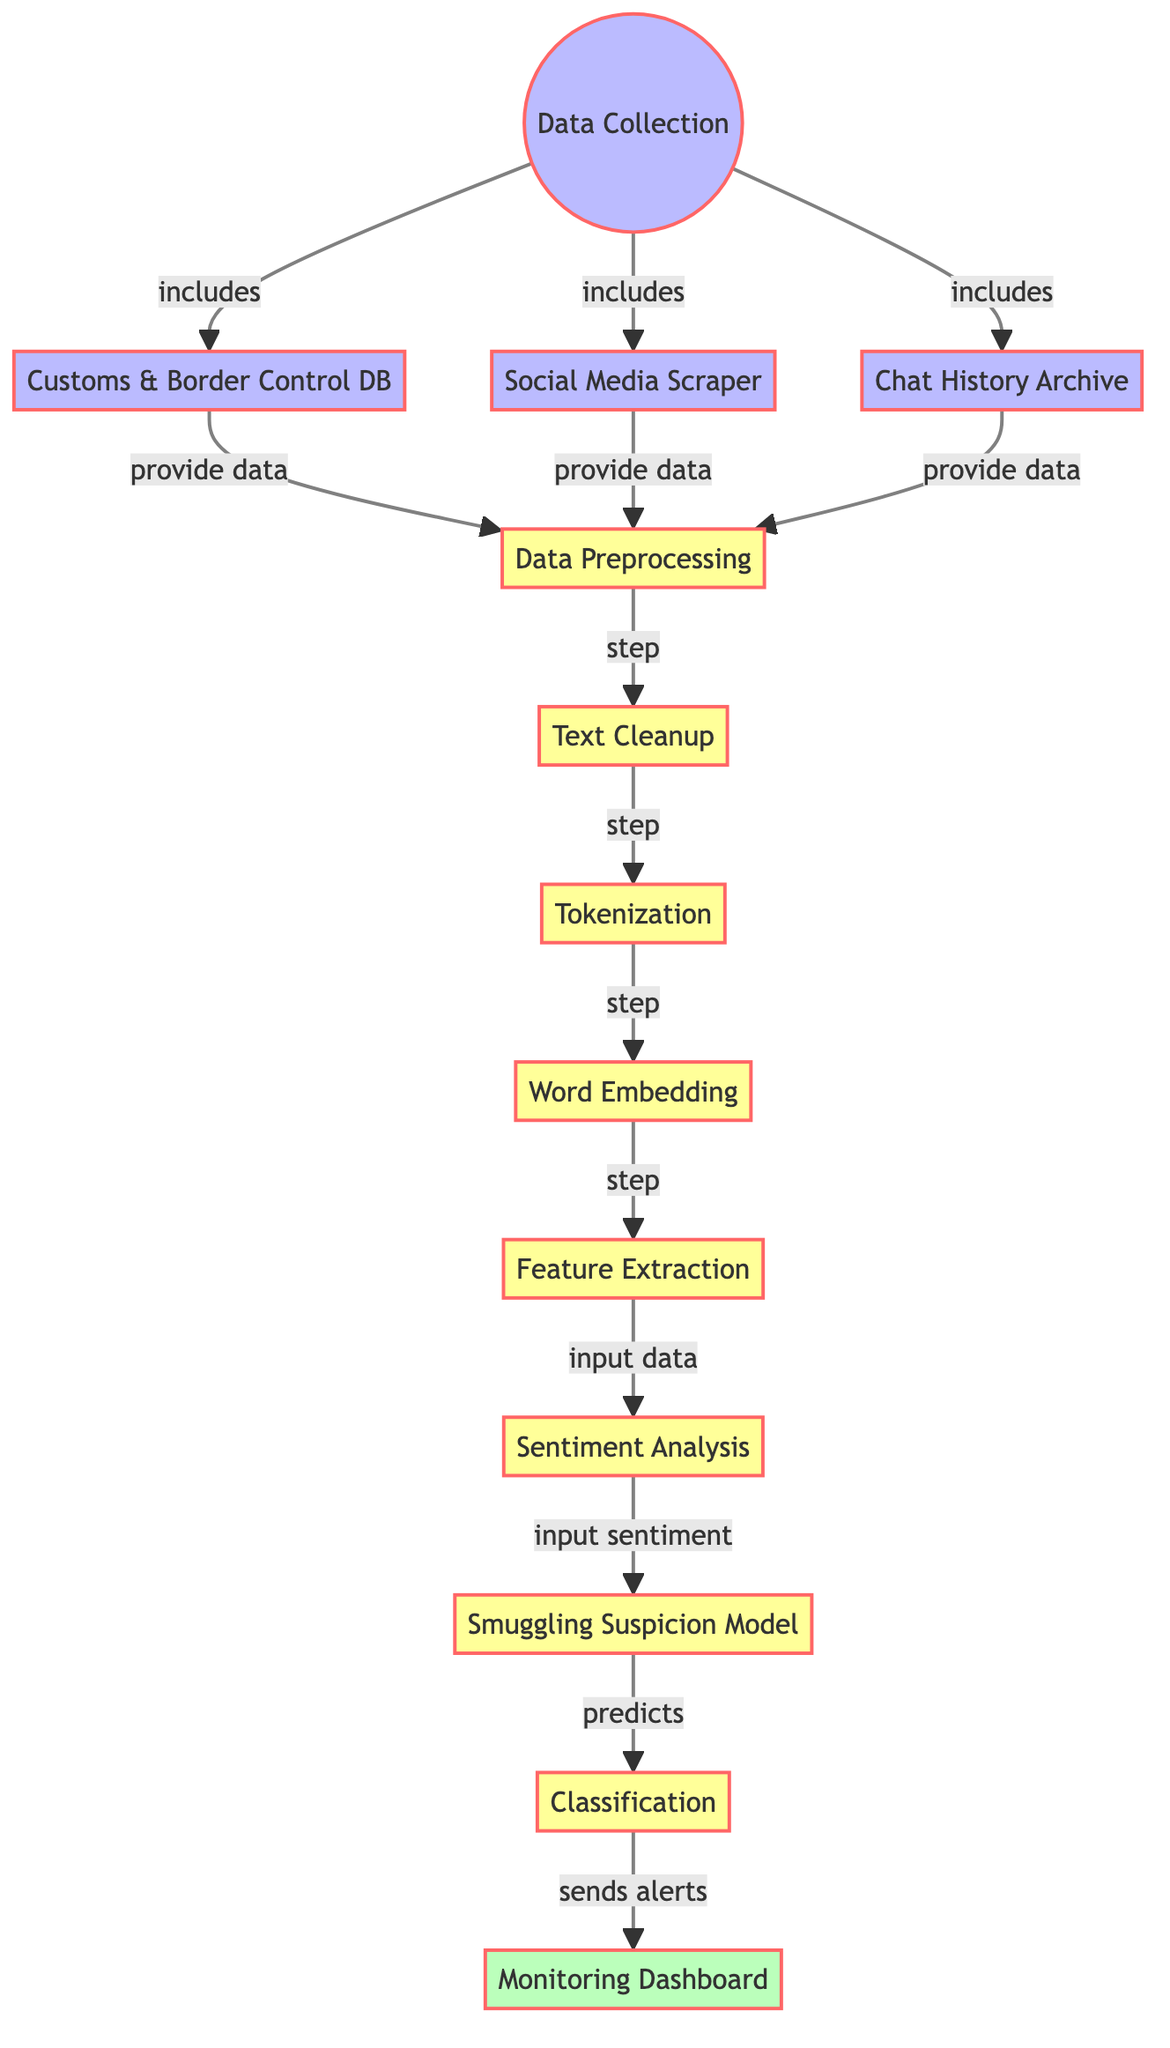What is the first step in the diagram? The diagram starts with "Data Collection", indicating that it's the first step in the process.
Answer: Data Collection How many data sources are there in the data collection step? There are three data sources shown: Customs & Border Control DB, Social Media Scraper, and Chat History Archive, which are all included in data collection.
Answer: Three What process follows text cleanup? According to the diagram, "Tokenization" is the next step that follows text cleanup.
Answer: Tokenization What is the final output of the process? The last node in the flowchart is "Monitoring Dashboard", which represents the final output of the process.
Answer: Monitoring Dashboard What type of model is used after sentiment analysis? The model described following sentiment analysis is labeled as "Smuggling Suspicion Model".
Answer: Smuggling Suspicion Model What does the classification step do? The classification step sends alerts to the monitoring dashboard, indicating its function within the diagram.
Answer: Sends alerts How many total processes are depicted in the diagram? Counting all the processing steps, there are six processes: data preprocessing, text cleanup, tokenization, word embedding, feature extraction, sentiment analysis, smuggling suspicion model, and classification.
Answer: Seven Which data source provides the data for preprocessing? All three sources: Customs & Border Control DB, Social Media Scraper, and Chat History Archive provide data to the preprocessing step in the diagram.
Answer: All three sources 